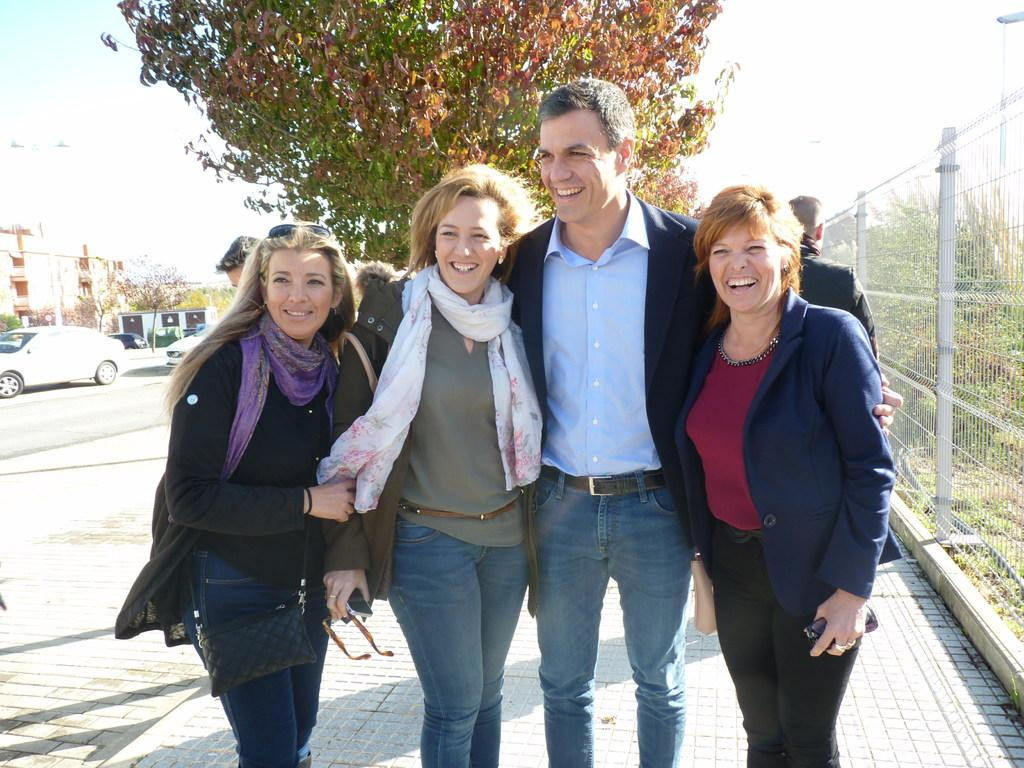How many people are in the image? There are four persons standing on a footpath in the image. What is located on the right side of the image? There is fencing on the right side of the image. What can be seen in the background of the image? There is a tree in the background of the image. What is visible on the left side of the image? There are cars on a road on the left side of the image. What type of instrument is being played by the person on the top of the tree? There is no person on top of the tree in the image, and no instrument is being played. 